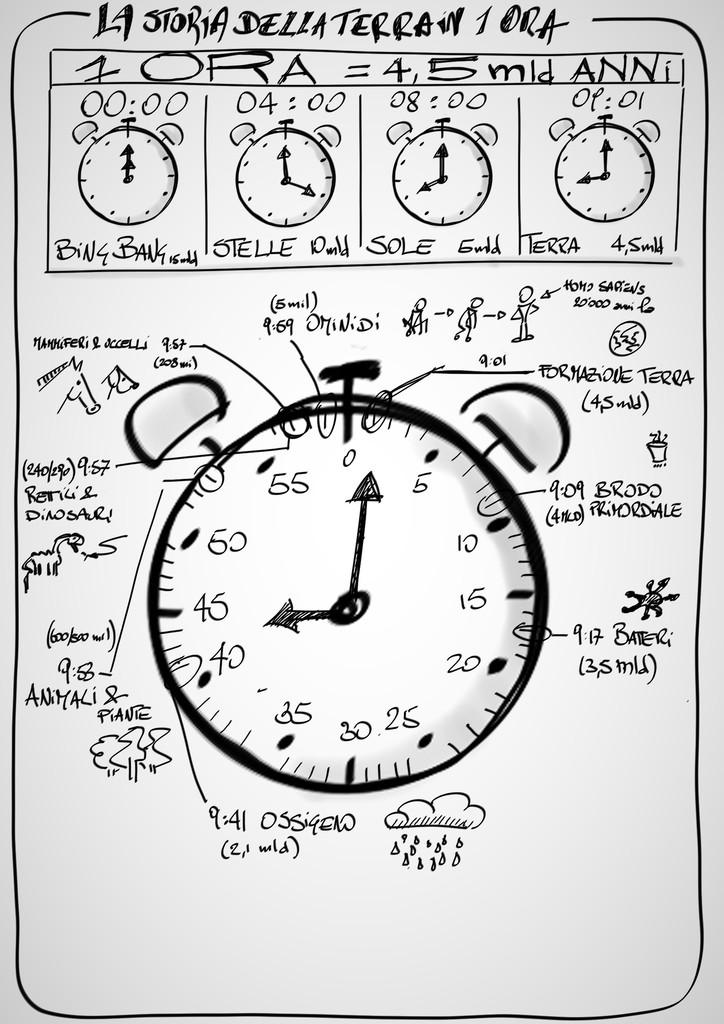<image>
Present a compact description of the photo's key features. La Storia Della Terrain 1 Ora paints a narrative with many clocks. 